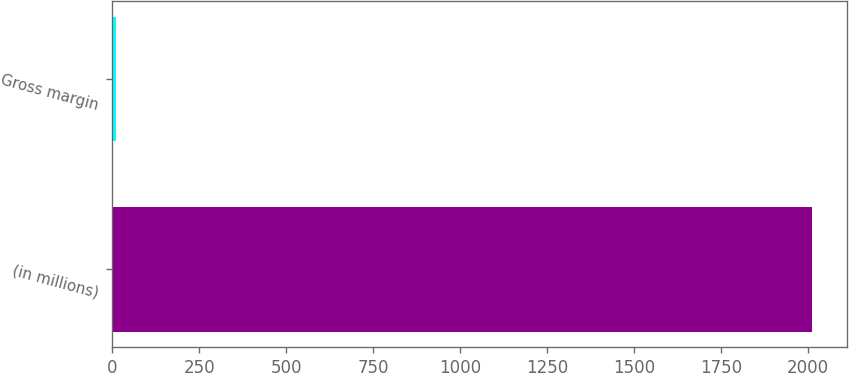Convert chart to OTSL. <chart><loc_0><loc_0><loc_500><loc_500><bar_chart><fcel>(in millions)<fcel>Gross margin<nl><fcel>2011<fcel>10<nl></chart> 